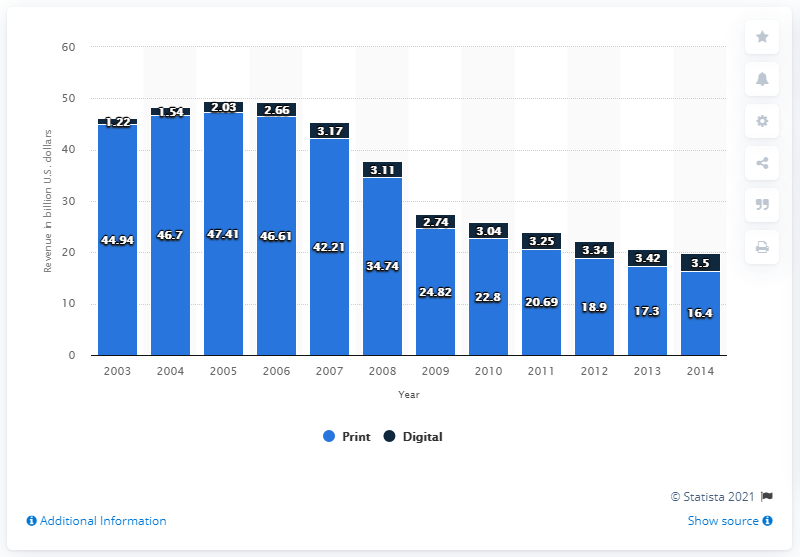Point out several critical features in this image. In 2014, newspapers spent 16.4 billion dollars selling print ad space. 